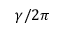<formula> <loc_0><loc_0><loc_500><loc_500>\gamma / 2 \pi</formula> 